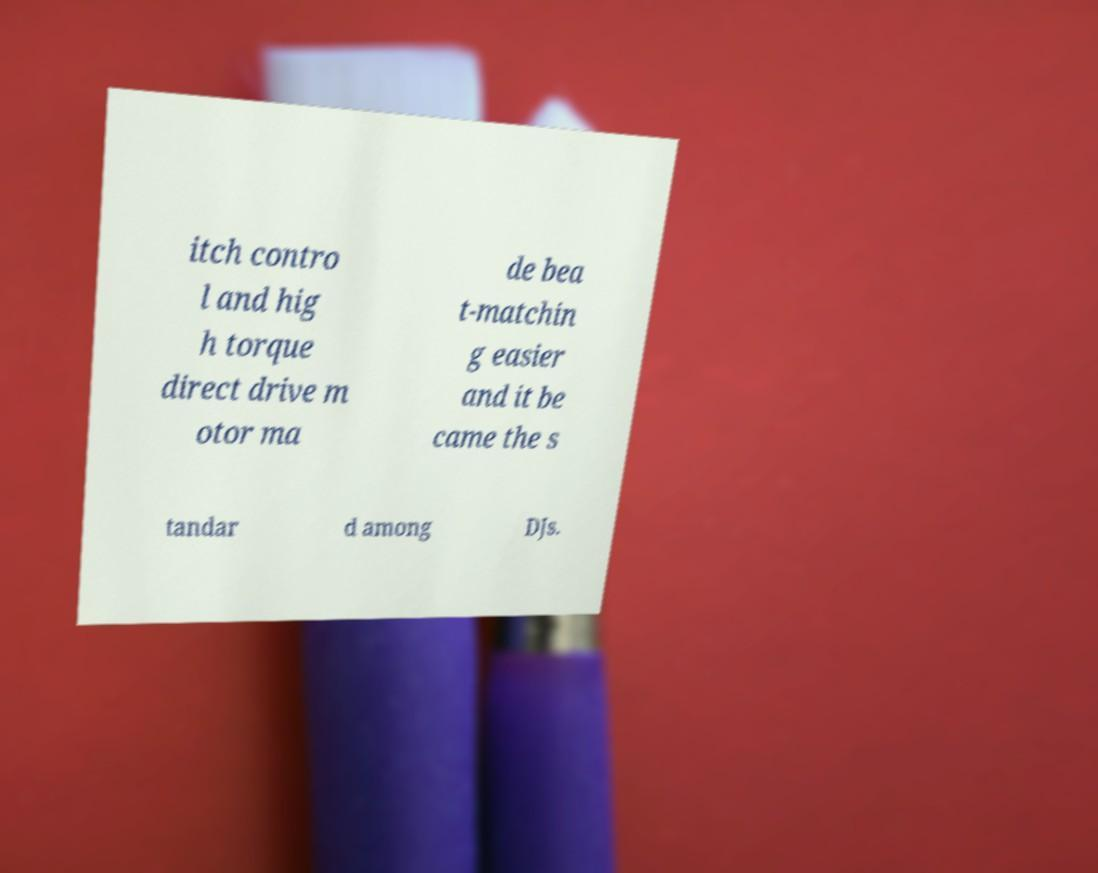What messages or text are displayed in this image? I need them in a readable, typed format. itch contro l and hig h torque direct drive m otor ma de bea t-matchin g easier and it be came the s tandar d among DJs. 